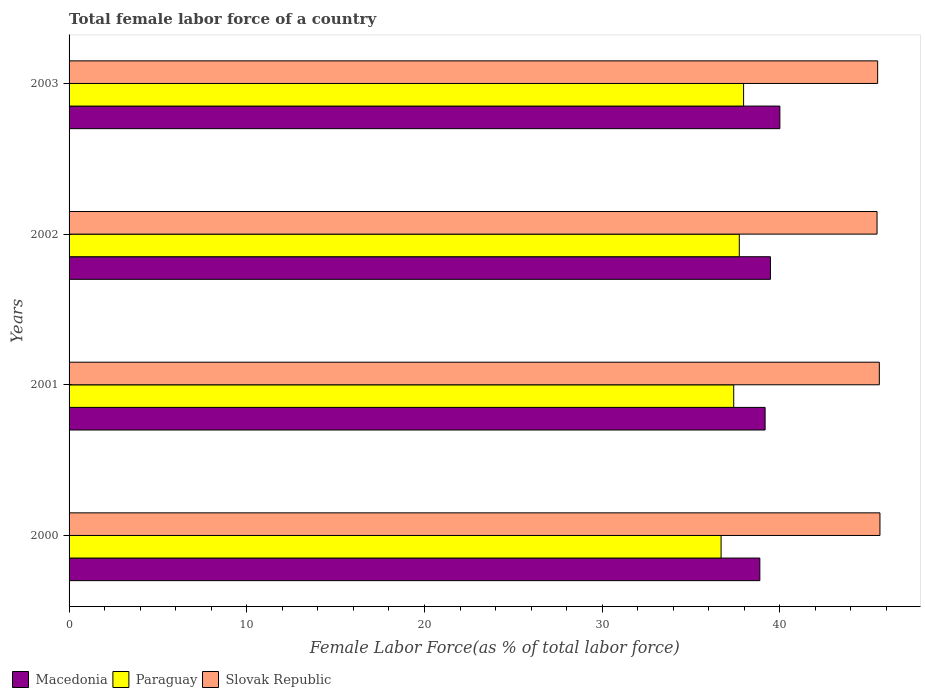How many different coloured bars are there?
Ensure brevity in your answer.  3. How many groups of bars are there?
Your answer should be compact. 4. Are the number of bars per tick equal to the number of legend labels?
Provide a succinct answer. Yes. How many bars are there on the 2nd tick from the top?
Give a very brief answer. 3. What is the percentage of female labor force in Macedonia in 2003?
Your answer should be compact. 40. Across all years, what is the maximum percentage of female labor force in Paraguay?
Ensure brevity in your answer.  37.96. Across all years, what is the minimum percentage of female labor force in Macedonia?
Your response must be concise. 38.87. In which year was the percentage of female labor force in Paraguay maximum?
Ensure brevity in your answer.  2003. In which year was the percentage of female labor force in Paraguay minimum?
Keep it short and to the point. 2000. What is the total percentage of female labor force in Macedonia in the graph?
Ensure brevity in your answer.  157.52. What is the difference between the percentage of female labor force in Slovak Republic in 2002 and that in 2003?
Keep it short and to the point. -0.03. What is the difference between the percentage of female labor force in Macedonia in 2000 and the percentage of female labor force in Slovak Republic in 2001?
Ensure brevity in your answer.  -6.72. What is the average percentage of female labor force in Macedonia per year?
Keep it short and to the point. 39.38. In the year 2001, what is the difference between the percentage of female labor force in Macedonia and percentage of female labor force in Slovak Republic?
Offer a terse response. -6.43. What is the ratio of the percentage of female labor force in Macedonia in 2000 to that in 2003?
Your response must be concise. 0.97. Is the percentage of female labor force in Slovak Republic in 2000 less than that in 2001?
Your response must be concise. No. What is the difference between the highest and the second highest percentage of female labor force in Macedonia?
Give a very brief answer. 0.53. What is the difference between the highest and the lowest percentage of female labor force in Macedonia?
Keep it short and to the point. 1.13. What does the 3rd bar from the top in 2001 represents?
Offer a very short reply. Macedonia. What does the 2nd bar from the bottom in 2002 represents?
Give a very brief answer. Paraguay. How many bars are there?
Ensure brevity in your answer.  12. How many years are there in the graph?
Provide a short and direct response. 4. Does the graph contain grids?
Provide a succinct answer. No. How are the legend labels stacked?
Give a very brief answer. Horizontal. What is the title of the graph?
Ensure brevity in your answer.  Total female labor force of a country. What is the label or title of the X-axis?
Make the answer very short. Female Labor Force(as % of total labor force). What is the Female Labor Force(as % of total labor force) in Macedonia in 2000?
Provide a succinct answer. 38.87. What is the Female Labor Force(as % of total labor force) of Paraguay in 2000?
Make the answer very short. 36.69. What is the Female Labor Force(as % of total labor force) in Slovak Republic in 2000?
Your response must be concise. 45.63. What is the Female Labor Force(as % of total labor force) of Macedonia in 2001?
Make the answer very short. 39.17. What is the Female Labor Force(as % of total labor force) in Paraguay in 2001?
Provide a succinct answer. 37.4. What is the Female Labor Force(as % of total labor force) of Slovak Republic in 2001?
Your answer should be compact. 45.6. What is the Female Labor Force(as % of total labor force) of Macedonia in 2002?
Your answer should be very brief. 39.47. What is the Female Labor Force(as % of total labor force) of Paraguay in 2002?
Provide a short and direct response. 37.72. What is the Female Labor Force(as % of total labor force) of Slovak Republic in 2002?
Make the answer very short. 45.47. What is the Female Labor Force(as % of total labor force) in Macedonia in 2003?
Make the answer very short. 40. What is the Female Labor Force(as % of total labor force) in Paraguay in 2003?
Make the answer very short. 37.96. What is the Female Labor Force(as % of total labor force) of Slovak Republic in 2003?
Your answer should be compact. 45.5. Across all years, what is the maximum Female Labor Force(as % of total labor force) in Macedonia?
Keep it short and to the point. 40. Across all years, what is the maximum Female Labor Force(as % of total labor force) in Paraguay?
Give a very brief answer. 37.96. Across all years, what is the maximum Female Labor Force(as % of total labor force) of Slovak Republic?
Your answer should be compact. 45.63. Across all years, what is the minimum Female Labor Force(as % of total labor force) in Macedonia?
Ensure brevity in your answer.  38.87. Across all years, what is the minimum Female Labor Force(as % of total labor force) in Paraguay?
Give a very brief answer. 36.69. Across all years, what is the minimum Female Labor Force(as % of total labor force) of Slovak Republic?
Your response must be concise. 45.47. What is the total Female Labor Force(as % of total labor force) of Macedonia in the graph?
Make the answer very short. 157.52. What is the total Female Labor Force(as % of total labor force) of Paraguay in the graph?
Your answer should be very brief. 149.78. What is the total Female Labor Force(as % of total labor force) in Slovak Republic in the graph?
Your response must be concise. 182.21. What is the difference between the Female Labor Force(as % of total labor force) of Macedonia in 2000 and that in 2001?
Offer a very short reply. -0.3. What is the difference between the Female Labor Force(as % of total labor force) in Paraguay in 2000 and that in 2001?
Make the answer very short. -0.71. What is the difference between the Female Labor Force(as % of total labor force) in Slovak Republic in 2000 and that in 2001?
Offer a very short reply. 0.03. What is the difference between the Female Labor Force(as % of total labor force) of Macedonia in 2000 and that in 2002?
Offer a very short reply. -0.6. What is the difference between the Female Labor Force(as % of total labor force) in Paraguay in 2000 and that in 2002?
Offer a very short reply. -1.02. What is the difference between the Female Labor Force(as % of total labor force) in Slovak Republic in 2000 and that in 2002?
Give a very brief answer. 0.16. What is the difference between the Female Labor Force(as % of total labor force) in Macedonia in 2000 and that in 2003?
Your answer should be compact. -1.13. What is the difference between the Female Labor Force(as % of total labor force) in Paraguay in 2000 and that in 2003?
Offer a very short reply. -1.27. What is the difference between the Female Labor Force(as % of total labor force) of Slovak Republic in 2000 and that in 2003?
Your answer should be very brief. 0.13. What is the difference between the Female Labor Force(as % of total labor force) in Macedonia in 2001 and that in 2002?
Keep it short and to the point. -0.3. What is the difference between the Female Labor Force(as % of total labor force) in Paraguay in 2001 and that in 2002?
Keep it short and to the point. -0.31. What is the difference between the Female Labor Force(as % of total labor force) of Slovak Republic in 2001 and that in 2002?
Make the answer very short. 0.13. What is the difference between the Female Labor Force(as % of total labor force) of Macedonia in 2001 and that in 2003?
Ensure brevity in your answer.  -0.83. What is the difference between the Female Labor Force(as % of total labor force) in Paraguay in 2001 and that in 2003?
Your answer should be compact. -0.56. What is the difference between the Female Labor Force(as % of total labor force) in Slovak Republic in 2001 and that in 2003?
Give a very brief answer. 0.09. What is the difference between the Female Labor Force(as % of total labor force) in Macedonia in 2002 and that in 2003?
Give a very brief answer. -0.53. What is the difference between the Female Labor Force(as % of total labor force) in Paraguay in 2002 and that in 2003?
Give a very brief answer. -0.24. What is the difference between the Female Labor Force(as % of total labor force) in Slovak Republic in 2002 and that in 2003?
Ensure brevity in your answer.  -0.03. What is the difference between the Female Labor Force(as % of total labor force) in Macedonia in 2000 and the Female Labor Force(as % of total labor force) in Paraguay in 2001?
Your response must be concise. 1.47. What is the difference between the Female Labor Force(as % of total labor force) in Macedonia in 2000 and the Female Labor Force(as % of total labor force) in Slovak Republic in 2001?
Ensure brevity in your answer.  -6.72. What is the difference between the Female Labor Force(as % of total labor force) in Paraguay in 2000 and the Female Labor Force(as % of total labor force) in Slovak Republic in 2001?
Provide a succinct answer. -8.91. What is the difference between the Female Labor Force(as % of total labor force) of Macedonia in 2000 and the Female Labor Force(as % of total labor force) of Paraguay in 2002?
Provide a short and direct response. 1.16. What is the difference between the Female Labor Force(as % of total labor force) in Macedonia in 2000 and the Female Labor Force(as % of total labor force) in Slovak Republic in 2002?
Your response must be concise. -6.6. What is the difference between the Female Labor Force(as % of total labor force) in Paraguay in 2000 and the Female Labor Force(as % of total labor force) in Slovak Republic in 2002?
Keep it short and to the point. -8.78. What is the difference between the Female Labor Force(as % of total labor force) in Macedonia in 2000 and the Female Labor Force(as % of total labor force) in Paraguay in 2003?
Make the answer very short. 0.91. What is the difference between the Female Labor Force(as % of total labor force) in Macedonia in 2000 and the Female Labor Force(as % of total labor force) in Slovak Republic in 2003?
Your answer should be very brief. -6.63. What is the difference between the Female Labor Force(as % of total labor force) of Paraguay in 2000 and the Female Labor Force(as % of total labor force) of Slovak Republic in 2003?
Offer a terse response. -8.81. What is the difference between the Female Labor Force(as % of total labor force) in Macedonia in 2001 and the Female Labor Force(as % of total labor force) in Paraguay in 2002?
Provide a succinct answer. 1.45. What is the difference between the Female Labor Force(as % of total labor force) of Macedonia in 2001 and the Female Labor Force(as % of total labor force) of Slovak Republic in 2002?
Your answer should be very brief. -6.3. What is the difference between the Female Labor Force(as % of total labor force) of Paraguay in 2001 and the Female Labor Force(as % of total labor force) of Slovak Republic in 2002?
Keep it short and to the point. -8.07. What is the difference between the Female Labor Force(as % of total labor force) in Macedonia in 2001 and the Female Labor Force(as % of total labor force) in Paraguay in 2003?
Offer a terse response. 1.21. What is the difference between the Female Labor Force(as % of total labor force) in Macedonia in 2001 and the Female Labor Force(as % of total labor force) in Slovak Republic in 2003?
Your answer should be compact. -6.33. What is the difference between the Female Labor Force(as % of total labor force) in Paraguay in 2001 and the Female Labor Force(as % of total labor force) in Slovak Republic in 2003?
Provide a short and direct response. -8.1. What is the difference between the Female Labor Force(as % of total labor force) in Macedonia in 2002 and the Female Labor Force(as % of total labor force) in Paraguay in 2003?
Provide a succinct answer. 1.51. What is the difference between the Female Labor Force(as % of total labor force) of Macedonia in 2002 and the Female Labor Force(as % of total labor force) of Slovak Republic in 2003?
Your response must be concise. -6.03. What is the difference between the Female Labor Force(as % of total labor force) of Paraguay in 2002 and the Female Labor Force(as % of total labor force) of Slovak Republic in 2003?
Provide a short and direct response. -7.79. What is the average Female Labor Force(as % of total labor force) in Macedonia per year?
Offer a very short reply. 39.38. What is the average Female Labor Force(as % of total labor force) in Paraguay per year?
Make the answer very short. 37.44. What is the average Female Labor Force(as % of total labor force) in Slovak Republic per year?
Provide a short and direct response. 45.55. In the year 2000, what is the difference between the Female Labor Force(as % of total labor force) of Macedonia and Female Labor Force(as % of total labor force) of Paraguay?
Offer a terse response. 2.18. In the year 2000, what is the difference between the Female Labor Force(as % of total labor force) of Macedonia and Female Labor Force(as % of total labor force) of Slovak Republic?
Give a very brief answer. -6.76. In the year 2000, what is the difference between the Female Labor Force(as % of total labor force) of Paraguay and Female Labor Force(as % of total labor force) of Slovak Republic?
Make the answer very short. -8.94. In the year 2001, what is the difference between the Female Labor Force(as % of total labor force) in Macedonia and Female Labor Force(as % of total labor force) in Paraguay?
Give a very brief answer. 1.77. In the year 2001, what is the difference between the Female Labor Force(as % of total labor force) of Macedonia and Female Labor Force(as % of total labor force) of Slovak Republic?
Provide a succinct answer. -6.43. In the year 2001, what is the difference between the Female Labor Force(as % of total labor force) in Paraguay and Female Labor Force(as % of total labor force) in Slovak Republic?
Provide a succinct answer. -8.19. In the year 2002, what is the difference between the Female Labor Force(as % of total labor force) in Macedonia and Female Labor Force(as % of total labor force) in Paraguay?
Offer a very short reply. 1.75. In the year 2002, what is the difference between the Female Labor Force(as % of total labor force) of Macedonia and Female Labor Force(as % of total labor force) of Slovak Republic?
Keep it short and to the point. -6. In the year 2002, what is the difference between the Female Labor Force(as % of total labor force) of Paraguay and Female Labor Force(as % of total labor force) of Slovak Republic?
Your answer should be compact. -7.75. In the year 2003, what is the difference between the Female Labor Force(as % of total labor force) in Macedonia and Female Labor Force(as % of total labor force) in Paraguay?
Your answer should be compact. 2.04. In the year 2003, what is the difference between the Female Labor Force(as % of total labor force) in Macedonia and Female Labor Force(as % of total labor force) in Slovak Republic?
Offer a very short reply. -5.5. In the year 2003, what is the difference between the Female Labor Force(as % of total labor force) in Paraguay and Female Labor Force(as % of total labor force) in Slovak Republic?
Make the answer very short. -7.54. What is the ratio of the Female Labor Force(as % of total labor force) of Macedonia in 2000 to that in 2001?
Offer a very short reply. 0.99. What is the ratio of the Female Labor Force(as % of total labor force) in Paraguay in 2000 to that in 2001?
Your response must be concise. 0.98. What is the ratio of the Female Labor Force(as % of total labor force) of Slovak Republic in 2000 to that in 2001?
Provide a short and direct response. 1. What is the ratio of the Female Labor Force(as % of total labor force) in Macedonia in 2000 to that in 2002?
Offer a very short reply. 0.98. What is the ratio of the Female Labor Force(as % of total labor force) in Paraguay in 2000 to that in 2002?
Provide a succinct answer. 0.97. What is the ratio of the Female Labor Force(as % of total labor force) of Slovak Republic in 2000 to that in 2002?
Offer a terse response. 1. What is the ratio of the Female Labor Force(as % of total labor force) in Macedonia in 2000 to that in 2003?
Your answer should be very brief. 0.97. What is the ratio of the Female Labor Force(as % of total labor force) in Paraguay in 2000 to that in 2003?
Provide a succinct answer. 0.97. What is the ratio of the Female Labor Force(as % of total labor force) in Macedonia in 2001 to that in 2002?
Provide a succinct answer. 0.99. What is the ratio of the Female Labor Force(as % of total labor force) in Paraguay in 2001 to that in 2002?
Your answer should be very brief. 0.99. What is the ratio of the Female Labor Force(as % of total labor force) of Slovak Republic in 2001 to that in 2002?
Keep it short and to the point. 1. What is the ratio of the Female Labor Force(as % of total labor force) in Macedonia in 2001 to that in 2003?
Give a very brief answer. 0.98. What is the ratio of the Female Labor Force(as % of total labor force) in Paraguay in 2001 to that in 2003?
Keep it short and to the point. 0.99. What is the ratio of the Female Labor Force(as % of total labor force) of Macedonia in 2002 to that in 2003?
Ensure brevity in your answer.  0.99. What is the ratio of the Female Labor Force(as % of total labor force) in Paraguay in 2002 to that in 2003?
Make the answer very short. 0.99. What is the difference between the highest and the second highest Female Labor Force(as % of total labor force) of Macedonia?
Provide a short and direct response. 0.53. What is the difference between the highest and the second highest Female Labor Force(as % of total labor force) in Paraguay?
Your response must be concise. 0.24. What is the difference between the highest and the second highest Female Labor Force(as % of total labor force) of Slovak Republic?
Your answer should be compact. 0.03. What is the difference between the highest and the lowest Female Labor Force(as % of total labor force) in Macedonia?
Keep it short and to the point. 1.13. What is the difference between the highest and the lowest Female Labor Force(as % of total labor force) in Paraguay?
Your response must be concise. 1.27. What is the difference between the highest and the lowest Female Labor Force(as % of total labor force) of Slovak Republic?
Keep it short and to the point. 0.16. 